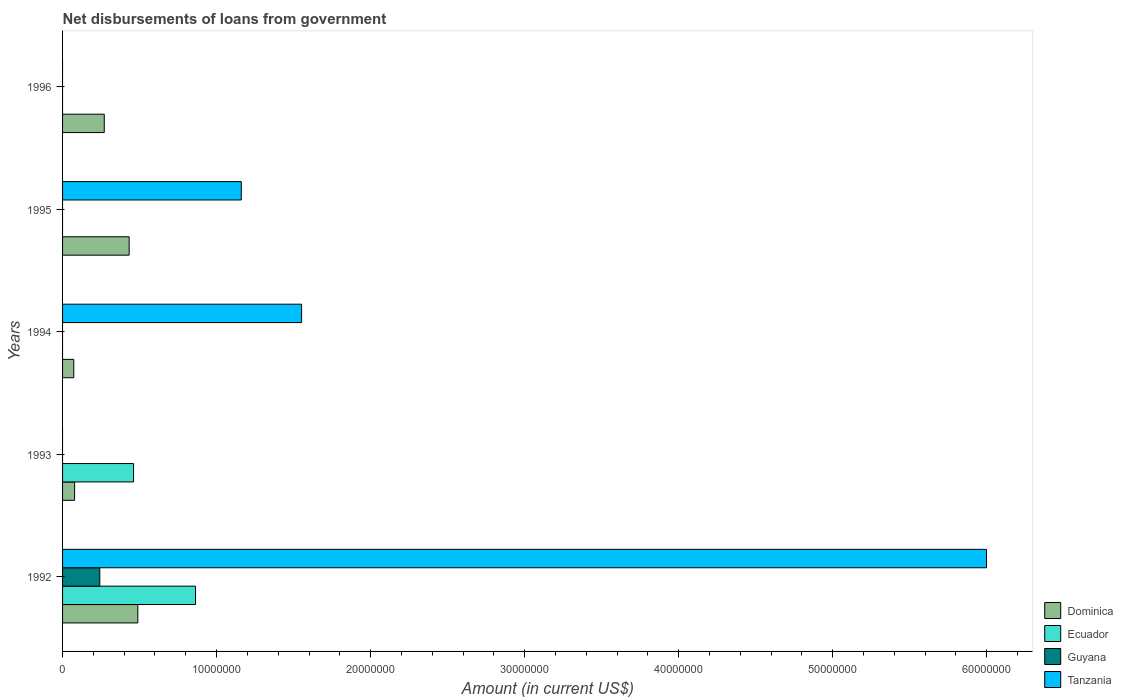How many bars are there on the 1st tick from the bottom?
Ensure brevity in your answer.  4. What is the label of the 2nd group of bars from the top?
Your response must be concise. 1995. Across all years, what is the maximum amount of loan disbursed from government in Guyana?
Offer a terse response. 2.42e+06. What is the total amount of loan disbursed from government in Dominica in the graph?
Offer a terse response. 1.34e+07. What is the difference between the amount of loan disbursed from government in Dominica in 1994 and that in 1995?
Offer a terse response. -3.60e+06. What is the difference between the amount of loan disbursed from government in Guyana in 1992 and the amount of loan disbursed from government in Ecuador in 1993?
Provide a short and direct response. -2.19e+06. What is the average amount of loan disbursed from government in Tanzania per year?
Offer a terse response. 1.74e+07. In the year 1992, what is the difference between the amount of loan disbursed from government in Ecuador and amount of loan disbursed from government in Guyana?
Provide a short and direct response. 6.22e+06. What is the ratio of the amount of loan disbursed from government in Dominica in 1993 to that in 1994?
Offer a terse response. 1.07. Is the amount of loan disbursed from government in Dominica in 1992 less than that in 1993?
Your response must be concise. No. What is the difference between the highest and the second highest amount of loan disbursed from government in Dominica?
Give a very brief answer. 5.63e+05. What is the difference between the highest and the lowest amount of loan disbursed from government in Dominica?
Make the answer very short. 4.16e+06. Are all the bars in the graph horizontal?
Ensure brevity in your answer.  Yes. How many years are there in the graph?
Provide a short and direct response. 5. What is the difference between two consecutive major ticks on the X-axis?
Offer a very short reply. 1.00e+07. Are the values on the major ticks of X-axis written in scientific E-notation?
Offer a terse response. No. Where does the legend appear in the graph?
Ensure brevity in your answer.  Bottom right. How are the legend labels stacked?
Provide a succinct answer. Vertical. What is the title of the graph?
Offer a very short reply. Net disbursements of loans from government. Does "Czech Republic" appear as one of the legend labels in the graph?
Ensure brevity in your answer.  No. What is the label or title of the X-axis?
Your response must be concise. Amount (in current US$). What is the Amount (in current US$) in Dominica in 1992?
Keep it short and to the point. 4.89e+06. What is the Amount (in current US$) of Ecuador in 1992?
Provide a short and direct response. 8.63e+06. What is the Amount (in current US$) of Guyana in 1992?
Your answer should be compact. 2.42e+06. What is the Amount (in current US$) of Tanzania in 1992?
Make the answer very short. 6.00e+07. What is the Amount (in current US$) of Dominica in 1993?
Offer a very short reply. 7.81e+05. What is the Amount (in current US$) of Ecuador in 1993?
Offer a terse response. 4.61e+06. What is the Amount (in current US$) of Guyana in 1993?
Your answer should be compact. 0. What is the Amount (in current US$) of Tanzania in 1993?
Offer a very short reply. 0. What is the Amount (in current US$) in Dominica in 1994?
Keep it short and to the point. 7.28e+05. What is the Amount (in current US$) of Ecuador in 1994?
Offer a very short reply. 0. What is the Amount (in current US$) in Tanzania in 1994?
Provide a short and direct response. 1.55e+07. What is the Amount (in current US$) of Dominica in 1995?
Your response must be concise. 4.32e+06. What is the Amount (in current US$) in Ecuador in 1995?
Your answer should be very brief. 0. What is the Amount (in current US$) in Guyana in 1995?
Give a very brief answer. 0. What is the Amount (in current US$) of Tanzania in 1995?
Your answer should be very brief. 1.16e+07. What is the Amount (in current US$) in Dominica in 1996?
Make the answer very short. 2.71e+06. What is the Amount (in current US$) of Guyana in 1996?
Ensure brevity in your answer.  0. What is the Amount (in current US$) in Tanzania in 1996?
Keep it short and to the point. 0. Across all years, what is the maximum Amount (in current US$) of Dominica?
Provide a succinct answer. 4.89e+06. Across all years, what is the maximum Amount (in current US$) in Ecuador?
Provide a succinct answer. 8.63e+06. Across all years, what is the maximum Amount (in current US$) in Guyana?
Your answer should be compact. 2.42e+06. Across all years, what is the maximum Amount (in current US$) in Tanzania?
Offer a very short reply. 6.00e+07. Across all years, what is the minimum Amount (in current US$) of Dominica?
Offer a terse response. 7.28e+05. Across all years, what is the minimum Amount (in current US$) of Ecuador?
Offer a terse response. 0. Across all years, what is the minimum Amount (in current US$) of Tanzania?
Offer a very short reply. 0. What is the total Amount (in current US$) of Dominica in the graph?
Offer a very short reply. 1.34e+07. What is the total Amount (in current US$) of Ecuador in the graph?
Your answer should be compact. 1.32e+07. What is the total Amount (in current US$) in Guyana in the graph?
Offer a very short reply. 2.42e+06. What is the total Amount (in current US$) in Tanzania in the graph?
Provide a short and direct response. 8.71e+07. What is the difference between the Amount (in current US$) of Dominica in 1992 and that in 1993?
Keep it short and to the point. 4.11e+06. What is the difference between the Amount (in current US$) in Ecuador in 1992 and that in 1993?
Give a very brief answer. 4.02e+06. What is the difference between the Amount (in current US$) of Dominica in 1992 and that in 1994?
Give a very brief answer. 4.16e+06. What is the difference between the Amount (in current US$) of Tanzania in 1992 and that in 1994?
Your answer should be compact. 4.45e+07. What is the difference between the Amount (in current US$) in Dominica in 1992 and that in 1995?
Give a very brief answer. 5.63e+05. What is the difference between the Amount (in current US$) of Tanzania in 1992 and that in 1995?
Make the answer very short. 4.84e+07. What is the difference between the Amount (in current US$) in Dominica in 1992 and that in 1996?
Keep it short and to the point. 2.18e+06. What is the difference between the Amount (in current US$) of Dominica in 1993 and that in 1994?
Offer a very short reply. 5.30e+04. What is the difference between the Amount (in current US$) in Dominica in 1993 and that in 1995?
Make the answer very short. -3.54e+06. What is the difference between the Amount (in current US$) of Dominica in 1993 and that in 1996?
Provide a short and direct response. -1.93e+06. What is the difference between the Amount (in current US$) in Dominica in 1994 and that in 1995?
Ensure brevity in your answer.  -3.60e+06. What is the difference between the Amount (in current US$) of Tanzania in 1994 and that in 1995?
Offer a very short reply. 3.92e+06. What is the difference between the Amount (in current US$) of Dominica in 1994 and that in 1996?
Provide a short and direct response. -1.98e+06. What is the difference between the Amount (in current US$) in Dominica in 1995 and that in 1996?
Ensure brevity in your answer.  1.62e+06. What is the difference between the Amount (in current US$) of Dominica in 1992 and the Amount (in current US$) of Ecuador in 1993?
Keep it short and to the point. 2.77e+05. What is the difference between the Amount (in current US$) in Dominica in 1992 and the Amount (in current US$) in Tanzania in 1994?
Offer a terse response. -1.06e+07. What is the difference between the Amount (in current US$) in Ecuador in 1992 and the Amount (in current US$) in Tanzania in 1994?
Offer a very short reply. -6.89e+06. What is the difference between the Amount (in current US$) in Guyana in 1992 and the Amount (in current US$) in Tanzania in 1994?
Your answer should be very brief. -1.31e+07. What is the difference between the Amount (in current US$) in Dominica in 1992 and the Amount (in current US$) in Tanzania in 1995?
Provide a succinct answer. -6.72e+06. What is the difference between the Amount (in current US$) of Ecuador in 1992 and the Amount (in current US$) of Tanzania in 1995?
Make the answer very short. -2.97e+06. What is the difference between the Amount (in current US$) of Guyana in 1992 and the Amount (in current US$) of Tanzania in 1995?
Give a very brief answer. -9.19e+06. What is the difference between the Amount (in current US$) in Dominica in 1993 and the Amount (in current US$) in Tanzania in 1994?
Your response must be concise. -1.47e+07. What is the difference between the Amount (in current US$) in Ecuador in 1993 and the Amount (in current US$) in Tanzania in 1994?
Keep it short and to the point. -1.09e+07. What is the difference between the Amount (in current US$) in Dominica in 1993 and the Amount (in current US$) in Tanzania in 1995?
Ensure brevity in your answer.  -1.08e+07. What is the difference between the Amount (in current US$) of Ecuador in 1993 and the Amount (in current US$) of Tanzania in 1995?
Provide a succinct answer. -6.99e+06. What is the difference between the Amount (in current US$) in Dominica in 1994 and the Amount (in current US$) in Tanzania in 1995?
Provide a short and direct response. -1.09e+07. What is the average Amount (in current US$) in Dominica per year?
Offer a terse response. 2.69e+06. What is the average Amount (in current US$) in Ecuador per year?
Your response must be concise. 2.65e+06. What is the average Amount (in current US$) of Guyana per year?
Provide a succinct answer. 4.83e+05. What is the average Amount (in current US$) of Tanzania per year?
Offer a very short reply. 1.74e+07. In the year 1992, what is the difference between the Amount (in current US$) of Dominica and Amount (in current US$) of Ecuador?
Provide a short and direct response. -3.75e+06. In the year 1992, what is the difference between the Amount (in current US$) of Dominica and Amount (in current US$) of Guyana?
Offer a very short reply. 2.47e+06. In the year 1992, what is the difference between the Amount (in current US$) in Dominica and Amount (in current US$) in Tanzania?
Provide a succinct answer. -5.51e+07. In the year 1992, what is the difference between the Amount (in current US$) in Ecuador and Amount (in current US$) in Guyana?
Offer a very short reply. 6.22e+06. In the year 1992, what is the difference between the Amount (in current US$) of Ecuador and Amount (in current US$) of Tanzania?
Your answer should be very brief. -5.14e+07. In the year 1992, what is the difference between the Amount (in current US$) of Guyana and Amount (in current US$) of Tanzania?
Provide a short and direct response. -5.76e+07. In the year 1993, what is the difference between the Amount (in current US$) of Dominica and Amount (in current US$) of Ecuador?
Offer a terse response. -3.83e+06. In the year 1994, what is the difference between the Amount (in current US$) in Dominica and Amount (in current US$) in Tanzania?
Provide a succinct answer. -1.48e+07. In the year 1995, what is the difference between the Amount (in current US$) in Dominica and Amount (in current US$) in Tanzania?
Your response must be concise. -7.28e+06. What is the ratio of the Amount (in current US$) of Dominica in 1992 to that in 1993?
Offer a terse response. 6.26. What is the ratio of the Amount (in current US$) of Ecuador in 1992 to that in 1993?
Give a very brief answer. 1.87. What is the ratio of the Amount (in current US$) in Dominica in 1992 to that in 1994?
Your answer should be very brief. 6.71. What is the ratio of the Amount (in current US$) of Tanzania in 1992 to that in 1994?
Offer a terse response. 3.87. What is the ratio of the Amount (in current US$) of Dominica in 1992 to that in 1995?
Make the answer very short. 1.13. What is the ratio of the Amount (in current US$) of Tanzania in 1992 to that in 1995?
Offer a terse response. 5.17. What is the ratio of the Amount (in current US$) of Dominica in 1992 to that in 1996?
Your response must be concise. 1.81. What is the ratio of the Amount (in current US$) of Dominica in 1993 to that in 1994?
Offer a very short reply. 1.07. What is the ratio of the Amount (in current US$) of Dominica in 1993 to that in 1995?
Keep it short and to the point. 0.18. What is the ratio of the Amount (in current US$) in Dominica in 1993 to that in 1996?
Provide a succinct answer. 0.29. What is the ratio of the Amount (in current US$) of Dominica in 1994 to that in 1995?
Ensure brevity in your answer.  0.17. What is the ratio of the Amount (in current US$) in Tanzania in 1994 to that in 1995?
Ensure brevity in your answer.  1.34. What is the ratio of the Amount (in current US$) of Dominica in 1994 to that in 1996?
Make the answer very short. 0.27. What is the ratio of the Amount (in current US$) of Dominica in 1995 to that in 1996?
Give a very brief answer. 1.6. What is the difference between the highest and the second highest Amount (in current US$) of Dominica?
Provide a succinct answer. 5.63e+05. What is the difference between the highest and the second highest Amount (in current US$) in Tanzania?
Your answer should be very brief. 4.45e+07. What is the difference between the highest and the lowest Amount (in current US$) of Dominica?
Keep it short and to the point. 4.16e+06. What is the difference between the highest and the lowest Amount (in current US$) in Ecuador?
Provide a succinct answer. 8.63e+06. What is the difference between the highest and the lowest Amount (in current US$) in Guyana?
Offer a very short reply. 2.42e+06. What is the difference between the highest and the lowest Amount (in current US$) of Tanzania?
Your answer should be very brief. 6.00e+07. 